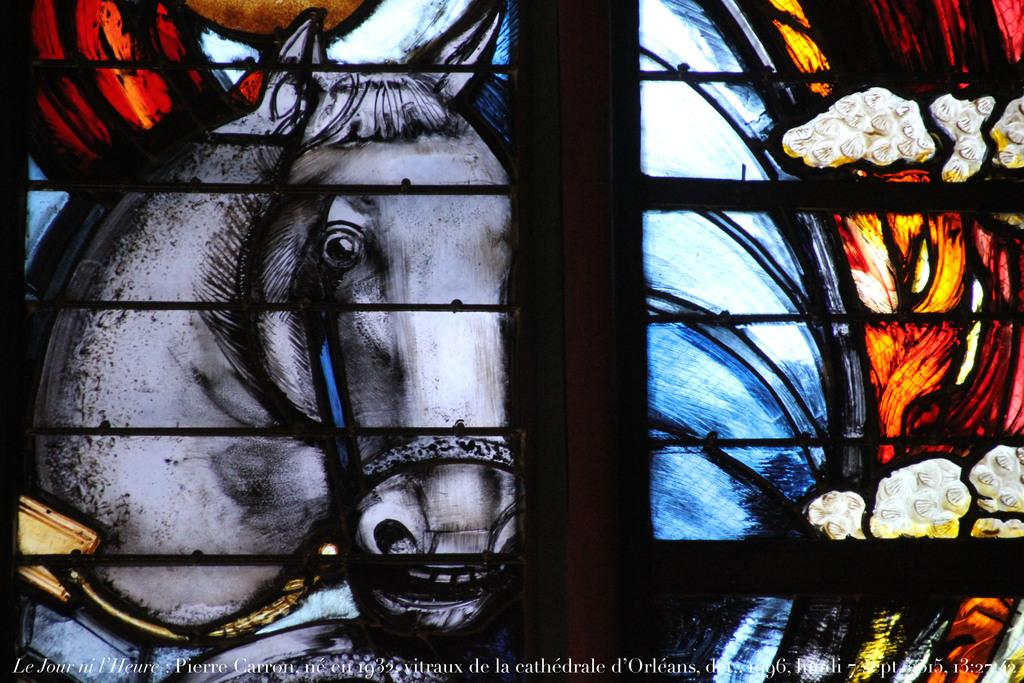What can be seen through the window in the image? The image does not show what can be seen through the window. What type of cooking appliance is visible in the image? There are grills in the image. What type of artwork is present in the image? There is a glass painting in the image. What is present at the bottom of the image? There is a watermark at the bottom of the image. What is the price of the zipper on the grills in the image? There is no zipper present in the image, and therefore no price can be determined. 